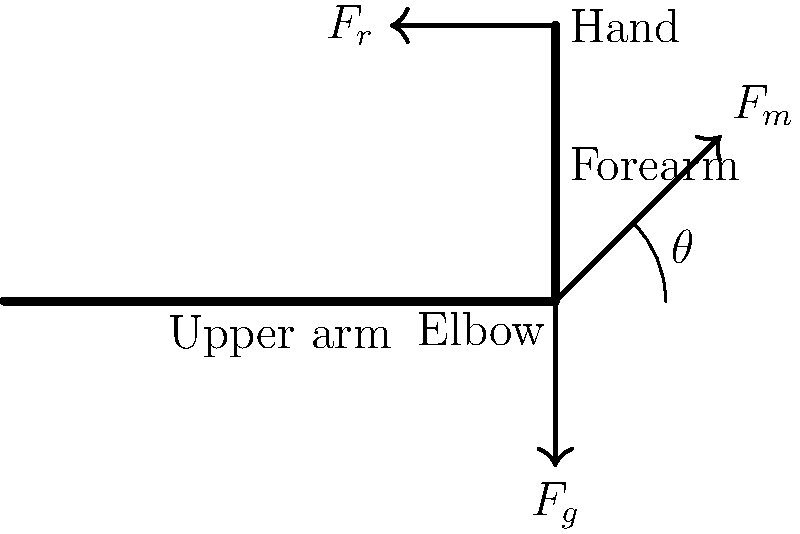In a physical therapy session, a patient is performing an arm curl exercise. The free-body diagram shows the forces acting on the forearm at a specific moment during the exercise. Given that the weight of the forearm (including the hand) is 20 N, the resistance force at the hand is 50 N, and the angle between the forearm and the upper arm is 45°, calculate the magnitude of the muscle force $F_m$ required to maintain this position. To solve this problem, we'll follow these steps:

1) Identify the forces acting on the forearm:
   - $F_g$: Weight of the forearm (20 N, acting downward)
   - $F_r$: Resistance force at the hand (50 N, acting to the left)
   - $F_m$: Muscle force at the elbow (unknown, acting upward and to the right)

2) Choose a coordinate system. Let's make the x-axis along the forearm and the y-axis perpendicular to it.

3) For equilibrium, the sum of forces in both x and y directions must be zero, and the sum of torques about any point must be zero. Let's sum the torques about the elbow.

4) The torque equation about the elbow:
   $\tau_{elbow} = F_r L \cos(0°) - F_g \frac{L}{2} \cos(45°) - F_m (0) = 0$
   Where L is the length of the forearm.

5) Simplify:
   $50L - 20 \frac{L}{2} \cos(45°) = 0$
   $50L - 10L \cos(45°) = 0$
   $50L - 10L (0.707) = 0$
   $50L - 7.07L = 0$
   $42.93L = 0$

6) The length L cancels out, showing that the muscle force is independent of the forearm length in this case.

7) To find $F_m$, we use the force balance equations:
   $\sum F_x = F_m \cos(45°) - F_r = 0$
   $F_m \cos(45°) = 50$
   $F_m = \frac{50}{\cos(45°)} = \frac{50}{0.707} = 70.71$ N

8) We can verify this using the y-component:
   $\sum F_y = F_m \sin(45°) - F_g = 0$
   $70.71 \sin(45°) - 20 = 0$
   $70.71 (0.707) - 20 = 0$
   $50 - 20 = 30$ N (upward force balancing the y-component of $F_r$)
Answer: 70.71 N 